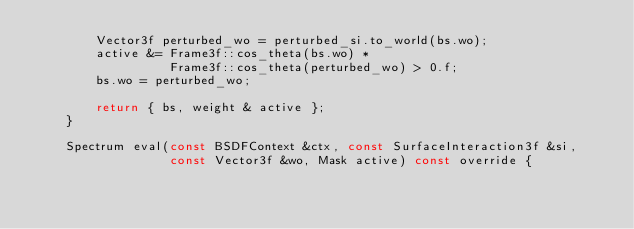<code> <loc_0><loc_0><loc_500><loc_500><_C++_>        Vector3f perturbed_wo = perturbed_si.to_world(bs.wo);
        active &= Frame3f::cos_theta(bs.wo) *
                  Frame3f::cos_theta(perturbed_wo) > 0.f;
        bs.wo = perturbed_wo;

        return { bs, weight & active };
    }

    Spectrum eval(const BSDFContext &ctx, const SurfaceInteraction3f &si,
                  const Vector3f &wo, Mask active) const override {</code> 